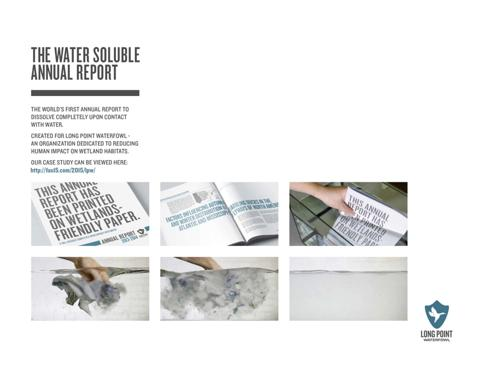Can you tell me more about how the dissolution of this paper in water serves as a metaphor for the organization? Certainly, the dissolution represents a powerful metaphor for transient human impact on natural wetlands. By choosing a water-soluble medium, Long Point Waterfowl emphasizes the ideal of leaving no lasting footprint on natural habitats, echoing the transient nature they wish human impacts on wetlands would have. 